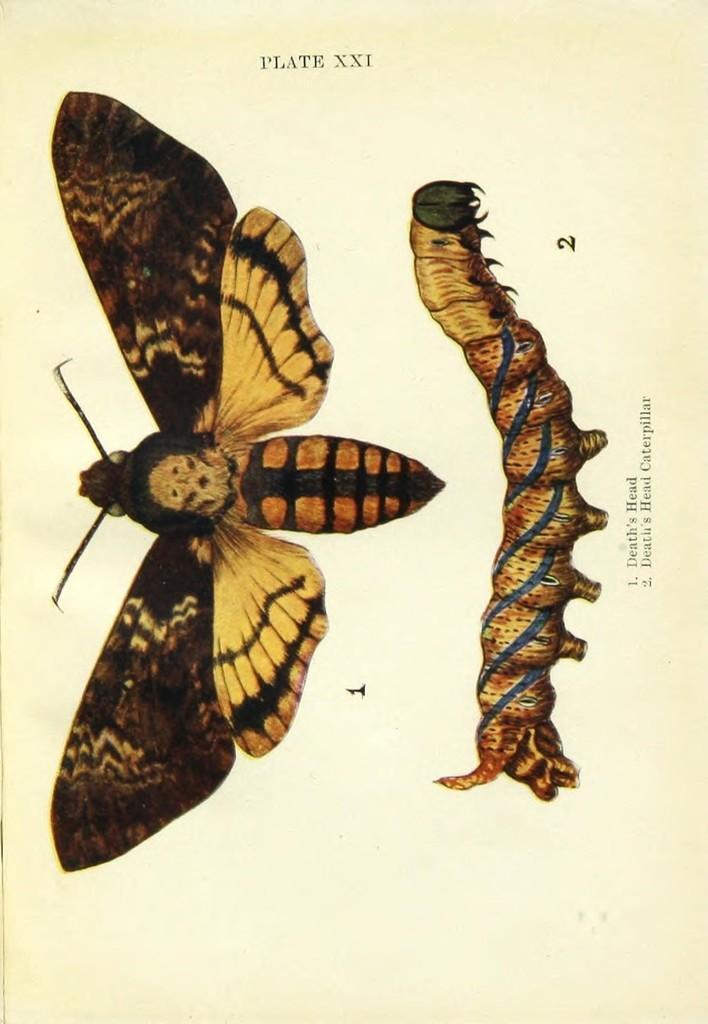How would you summarize this image in a sentence or two? In this image we can see the pictures of a butterfly and a caterpillar. We can also see some text on this image. 